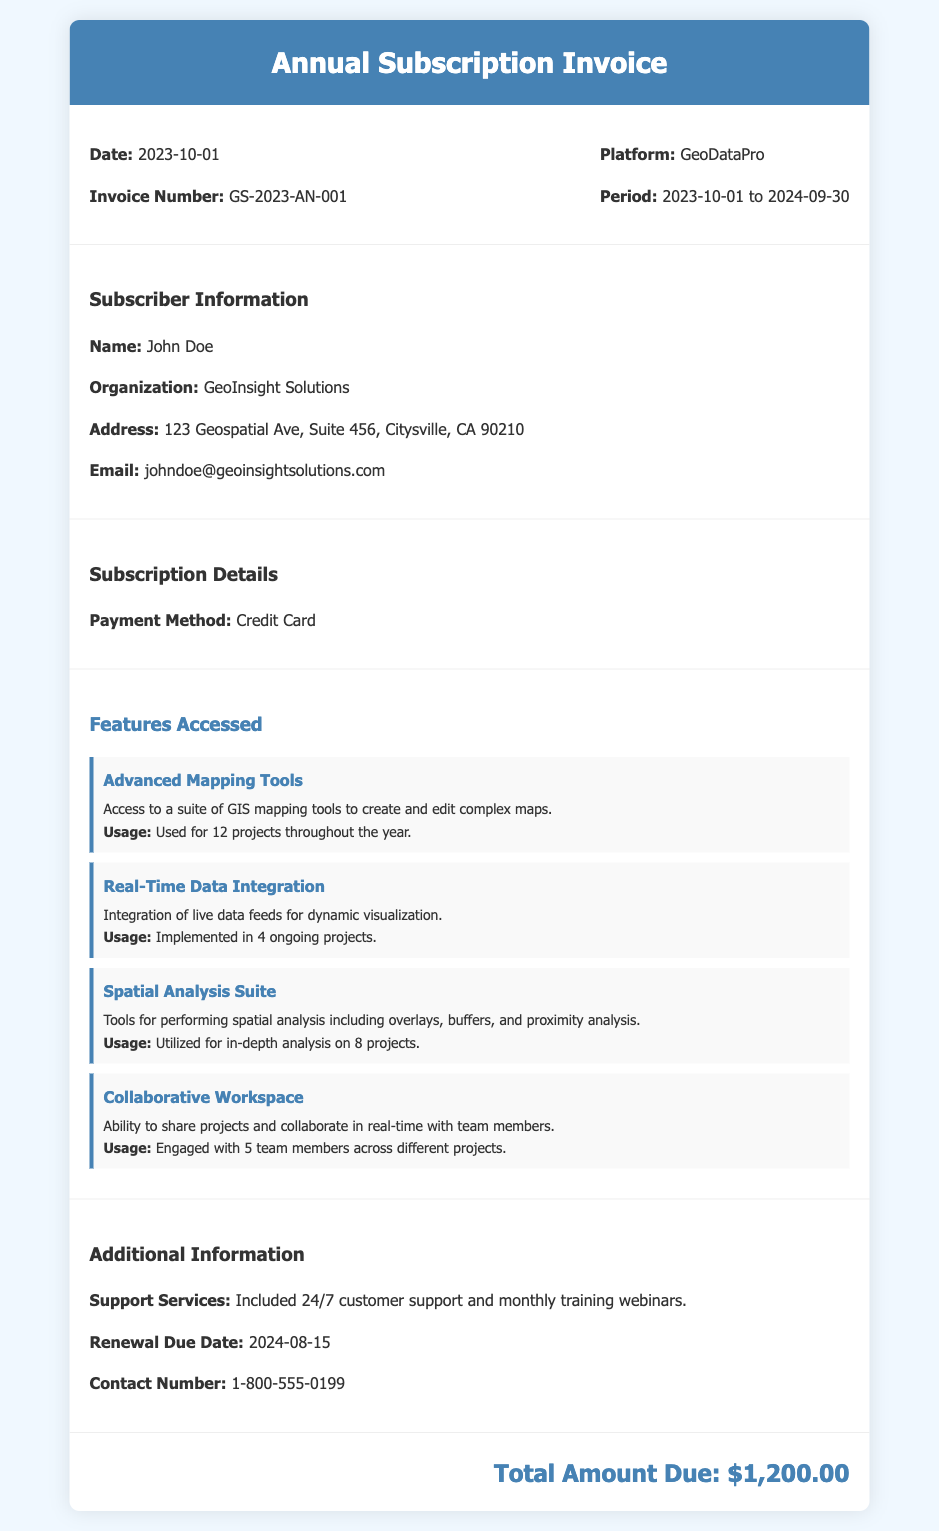what is the invoice number? The invoice number is provided in the invoice details section.
Answer: GS-2023-AN-001 who is the subscriber? The subscriber's name is listed under subscriber information.
Answer: John Doe what is the total amount due? The total amount due is mentioned at the bottom of the document.
Answer: $1,200.00 what is the payment method? The payment method is specified in the subscription details section.
Answer: Credit Card how many projects utilized the Advanced Mapping Tools? The usage of Advanced Mapping Tools is detailed in the features accessed section.
Answer: 12 projects what is the renewal due date? The renewal due date is mentioned in the additional information section.
Answer: 2024-08-15 which organization is associated with the subscriber? The organization name is included in the subscriber information.
Answer: GeoInsight Solutions how many team members engaged in the Collaborative Workspace feature? The number of team members engaged is detailed in the features accessed section.
Answer: 5 team members what is the platform name? The platform name is provided in the invoice details section.
Answer: GeoDataPro 